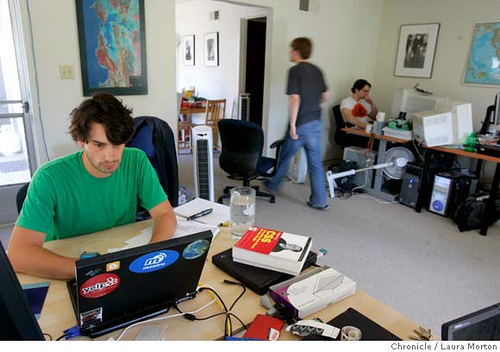Read all the text in this image. Chronicle 